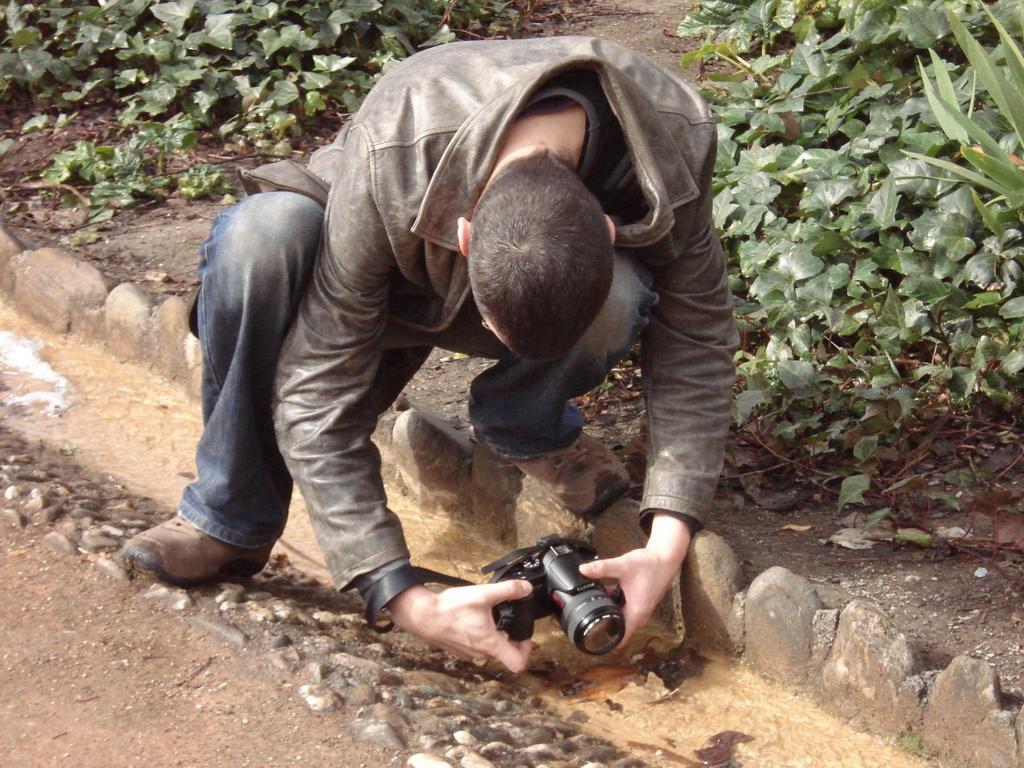Can you describe this image briefly? In this picture there is a man who is wearing a jacket and holding a camera in his hands taking picture in the bending position and there are some leaves, plants on the other side of him and some stones under his right leg. 